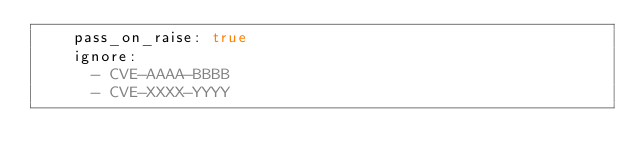<code> <loc_0><loc_0><loc_500><loc_500><_YAML_>    pass_on_raise: true
    ignore:
      - CVE-AAAA-BBBB
      - CVE-XXXX-YYYY
</code> 